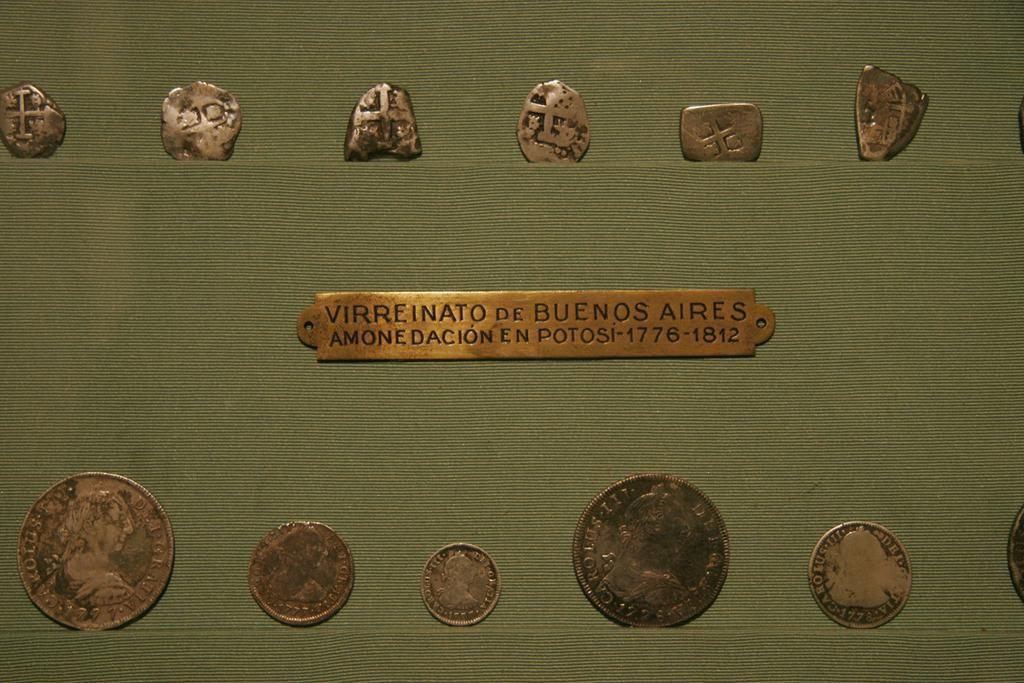Provide a one-sentence caption for the provided image. a series of old metal coins with an id tag reading virreinato de buenos aires between them. 